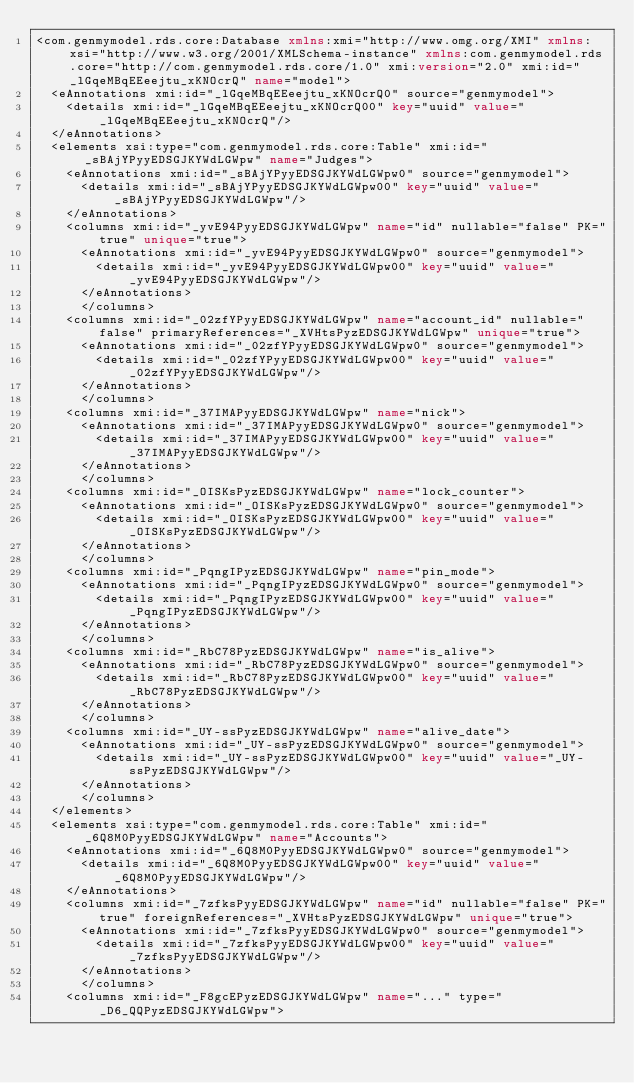Convert code to text. <code><loc_0><loc_0><loc_500><loc_500><_XML_><com.genmymodel.rds.core:Database xmlns:xmi="http://www.omg.org/XMI" xmlns:xsi="http://www.w3.org/2001/XMLSchema-instance" xmlns:com.genmymodel.rds.core="http://com.genmymodel.rds.core/1.0" xmi:version="2.0" xmi:id="_lGqeMBqEEeejtu_xKNOcrQ" name="model">
  <eAnnotations xmi:id="_lGqeMBqEEeejtu_xKNOcrQ0" source="genmymodel">
    <details xmi:id="_lGqeMBqEEeejtu_xKNOcrQ00" key="uuid" value="_lGqeMBqEEeejtu_xKNOcrQ"/>
  </eAnnotations>
  <elements xsi:type="com.genmymodel.rds.core:Table" xmi:id="_sBAjYPyyEDSGJKYWdLGWpw" name="Judges">
    <eAnnotations xmi:id="_sBAjYPyyEDSGJKYWdLGWpw0" source="genmymodel">
      <details xmi:id="_sBAjYPyyEDSGJKYWdLGWpw00" key="uuid" value="_sBAjYPyyEDSGJKYWdLGWpw"/>
    </eAnnotations>
    <columns xmi:id="_yvE94PyyEDSGJKYWdLGWpw" name="id" nullable="false" PK="true" unique="true">
      <eAnnotations xmi:id="_yvE94PyyEDSGJKYWdLGWpw0" source="genmymodel">
        <details xmi:id="_yvE94PyyEDSGJKYWdLGWpw00" key="uuid" value="_yvE94PyyEDSGJKYWdLGWpw"/>
      </eAnnotations>
      </columns>
    <columns xmi:id="_02zfYPyyEDSGJKYWdLGWpw" name="account_id" nullable="false" primaryReferences="_XVHtsPyzEDSGJKYWdLGWpw" unique="true">
      <eAnnotations xmi:id="_02zfYPyyEDSGJKYWdLGWpw0" source="genmymodel">
        <details xmi:id="_02zfYPyyEDSGJKYWdLGWpw00" key="uuid" value="_02zfYPyyEDSGJKYWdLGWpw"/>
      </eAnnotations>
      </columns>
    <columns xmi:id="_37IMAPyyEDSGJKYWdLGWpw" name="nick">
      <eAnnotations xmi:id="_37IMAPyyEDSGJKYWdLGWpw0" source="genmymodel">
        <details xmi:id="_37IMAPyyEDSGJKYWdLGWpw00" key="uuid" value="_37IMAPyyEDSGJKYWdLGWpw"/>
      </eAnnotations>
      </columns>
    <columns xmi:id="_OISKsPyzEDSGJKYWdLGWpw" name="lock_counter">
      <eAnnotations xmi:id="_OISKsPyzEDSGJKYWdLGWpw0" source="genmymodel">
        <details xmi:id="_OISKsPyzEDSGJKYWdLGWpw00" key="uuid" value="_OISKsPyzEDSGJKYWdLGWpw"/>
      </eAnnotations>
      </columns>
    <columns xmi:id="_PqngIPyzEDSGJKYWdLGWpw" name="pin_mode">
      <eAnnotations xmi:id="_PqngIPyzEDSGJKYWdLGWpw0" source="genmymodel">
        <details xmi:id="_PqngIPyzEDSGJKYWdLGWpw00" key="uuid" value="_PqngIPyzEDSGJKYWdLGWpw"/>
      </eAnnotations>
      </columns>
    <columns xmi:id="_RbC78PyzEDSGJKYWdLGWpw" name="is_alive">
      <eAnnotations xmi:id="_RbC78PyzEDSGJKYWdLGWpw0" source="genmymodel">
        <details xmi:id="_RbC78PyzEDSGJKYWdLGWpw00" key="uuid" value="_RbC78PyzEDSGJKYWdLGWpw"/>
      </eAnnotations>
      </columns>
    <columns xmi:id="_UY-ssPyzEDSGJKYWdLGWpw" name="alive_date">
      <eAnnotations xmi:id="_UY-ssPyzEDSGJKYWdLGWpw0" source="genmymodel">
        <details xmi:id="_UY-ssPyzEDSGJKYWdLGWpw00" key="uuid" value="_UY-ssPyzEDSGJKYWdLGWpw"/>
      </eAnnotations>
      </columns>
  </elements>
  <elements xsi:type="com.genmymodel.rds.core:Table" xmi:id="_6Q8M0PyyEDSGJKYWdLGWpw" name="Accounts">
    <eAnnotations xmi:id="_6Q8M0PyyEDSGJKYWdLGWpw0" source="genmymodel">
      <details xmi:id="_6Q8M0PyyEDSGJKYWdLGWpw00" key="uuid" value="_6Q8M0PyyEDSGJKYWdLGWpw"/>
    </eAnnotations>
    <columns xmi:id="_7zfksPyyEDSGJKYWdLGWpw" name="id" nullable="false" PK="true" foreignReferences="_XVHtsPyzEDSGJKYWdLGWpw" unique="true">
      <eAnnotations xmi:id="_7zfksPyyEDSGJKYWdLGWpw0" source="genmymodel">
        <details xmi:id="_7zfksPyyEDSGJKYWdLGWpw00" key="uuid" value="_7zfksPyyEDSGJKYWdLGWpw"/>
      </eAnnotations>
      </columns>
    <columns xmi:id="_F8gcEPyzEDSGJKYWdLGWpw" name="..." type="_D6_QQPyzEDSGJKYWdLGWpw"></code> 